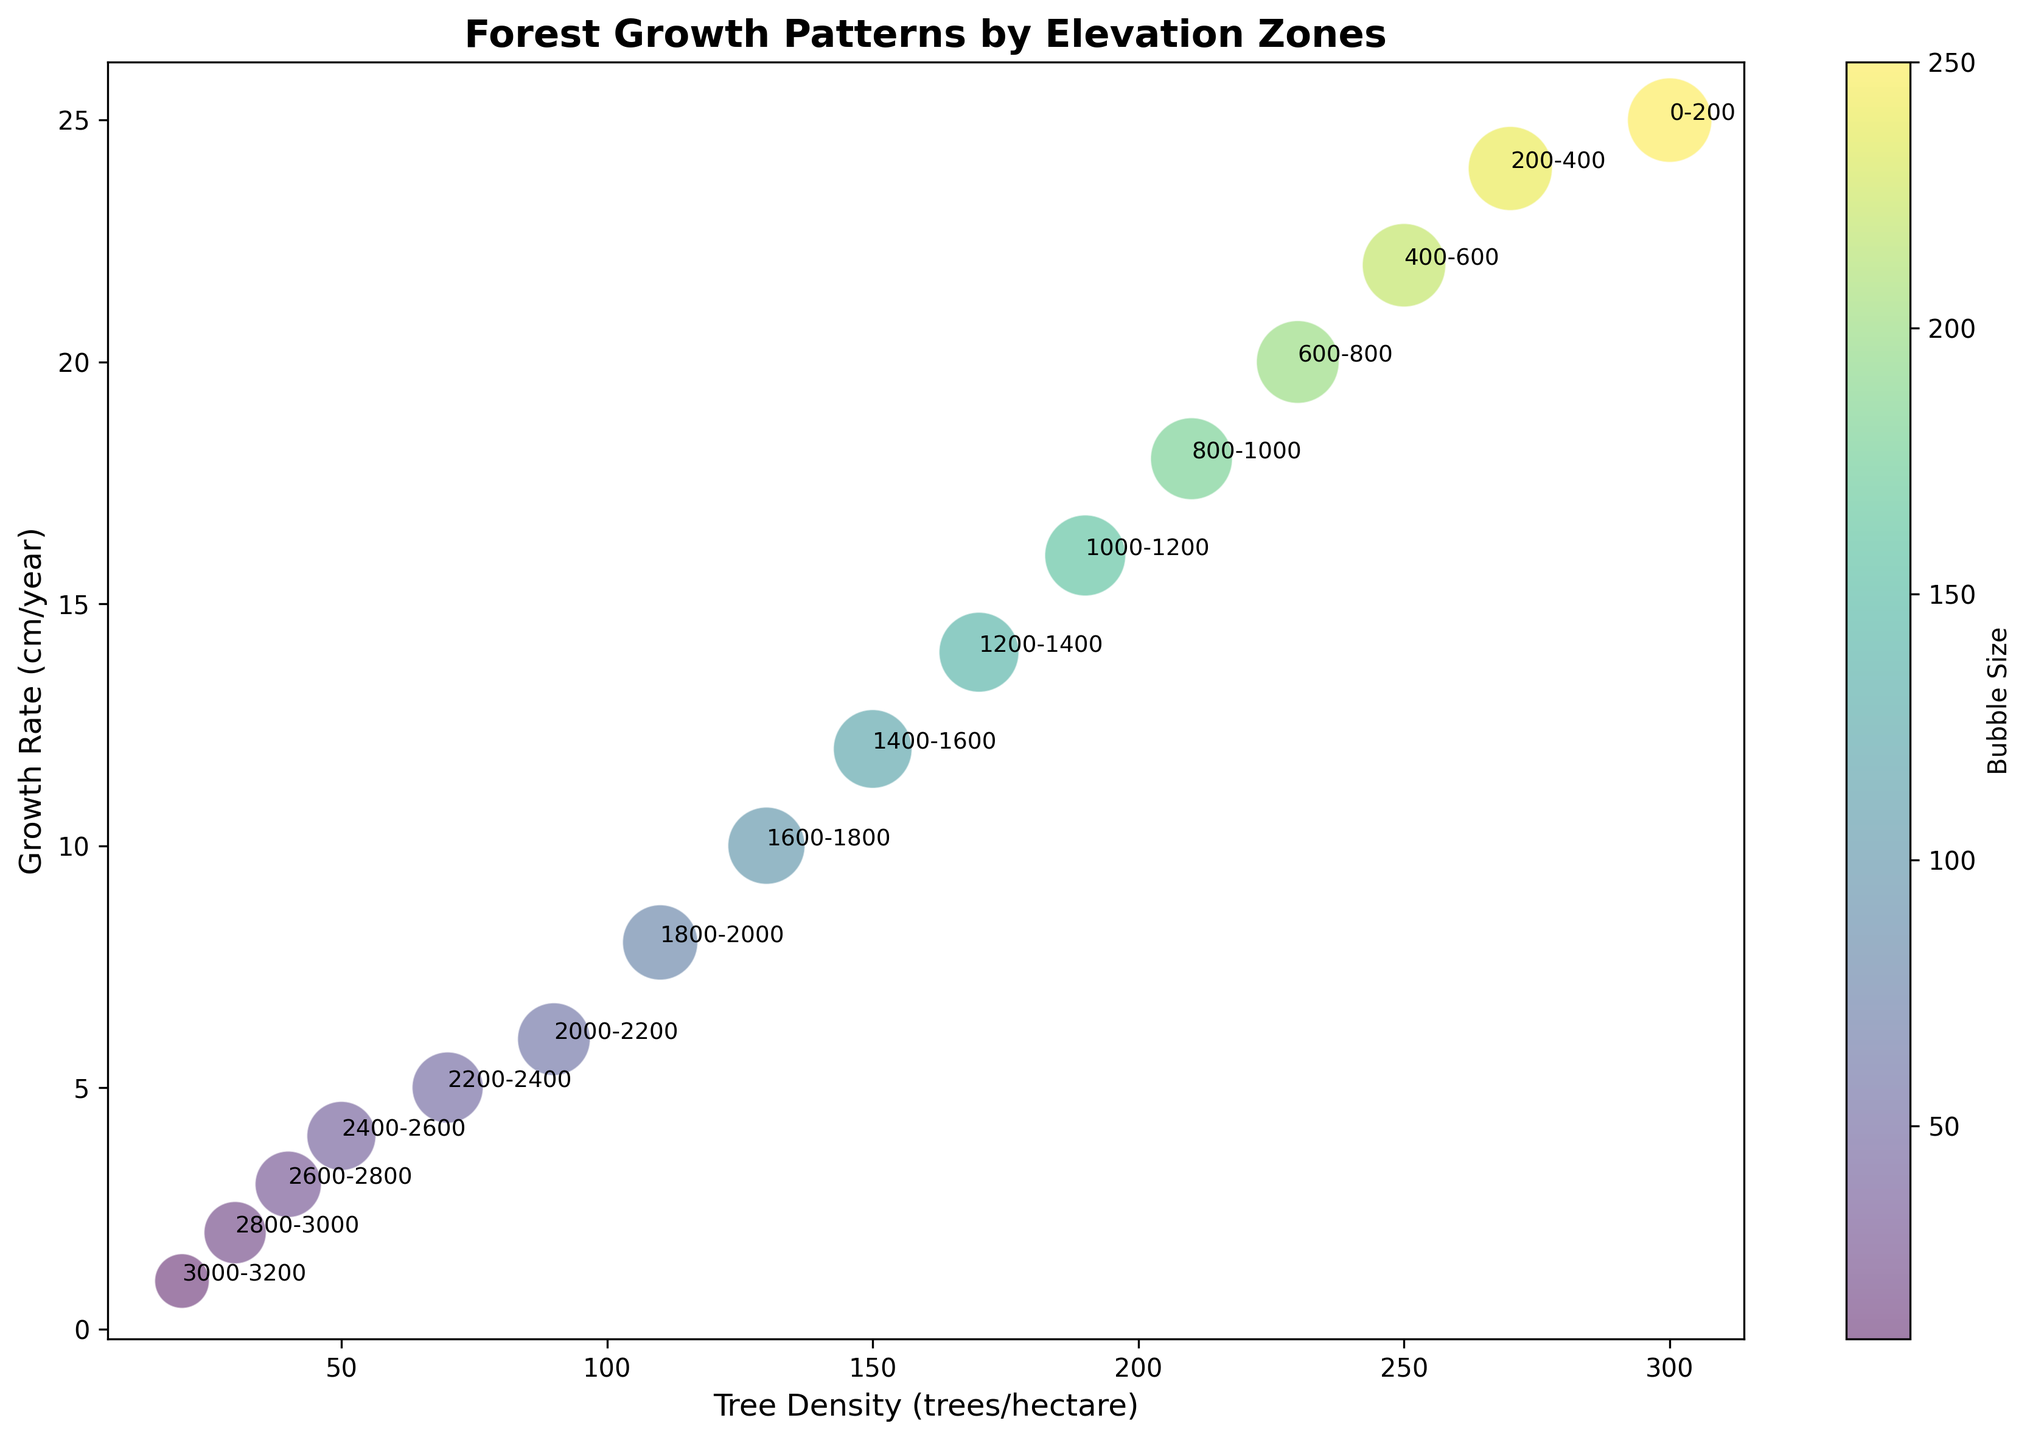Which elevation zone has the highest tree density? Look at the bubble nearest to the highest value on the tree density axis. The 0-200 meters elevation zone has the highest tree density at 300 trees/hectare.
Answer: 0-200 meters How does the growth rate change as elevation increases from 200-400 meters to 1600-1800 meters? Compare the growth rates for each elevation zone between 200-400 meters and 1600-1800 meters. At 200-400 meters, the growth rate is 24 cm/year, while at 1600-1800 meters, it drops to 10 cm/year.
Answer: It decreases Which elevation zone has the smallest bubble size? Find the smallest bubble size on the plot. The smallest bubble corresponds to the 3000-3200 meters elevation zone with a size of 10.
Answer: 3000-3200 meters What is the difference in growth rates between the 0-200 meters and 1000-1200 meters elevation zones? The growth rate at 0-200 meters is 25 cm/year, and at 1000-1200 meters, it is 16 cm/year. The difference is 25 - 16 = 9 cm/year.
Answer: 9 cm/year Is there any correlation between tree density and growth rate? By observing the plot, we see that as tree density decreases, growth rate also decreases, suggesting a positive correlation.
Answer: Yes Which elevation zone corresponds to the bubble with the color closest to green? Examine the bubbles with colors ranging from yellow to green, which corresponds to medium-sized bubbles. This is around the 1400-1600 meters elevation zone.
Answer: 1400-1600 meters Compared to elevation zones 0-200 meters and 800-1000 meters, which has a higher growth rate? Compare the growth rates: 0-200 meters has 25 cm/year while 800-1000 meters has 18 cm/year.
Answer: 0-200 meters Identify the elevation zone with the highest growth rate and calculate the ratio of its tree density to that of the elevation with the lowest growth rate. The highest growth rate is at 0-200 meters, with 300 trees/hectare. The lowest growth rate is at 3000-3200 meters, with 20 trees/hectare. The ratio is 300/20 = 15.
Answer: 15 Which elevation zones have tree densities above 100 trees/hectare but growth rates below 15 cm/year? Check the plot for bubbles where tree density is above 100 and growth rate is below 15. These zones are 1200-1400 meters, 1400-1600 meters, and 1600-1800 meters.
Answer: 1200-1400, 1400-1600, 1600-1800 meters 